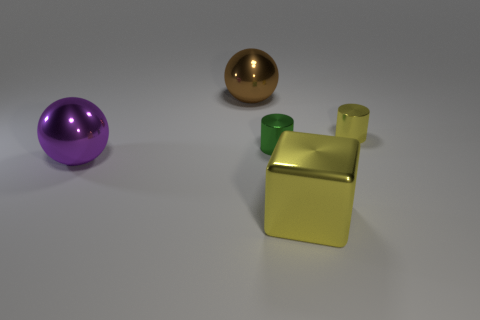There is a yellow metallic object that is on the left side of the small yellow cylinder; how big is it?
Keep it short and to the point. Large. How many cyan spheres are the same size as the brown metal sphere?
Your answer should be compact. 0. There is a yellow metal cube; is its size the same as the green thing right of the purple ball?
Your response must be concise. No. How many things are either metallic cylinders or tiny yellow things?
Your answer should be compact. 2. What number of cylinders are the same color as the large metal block?
Provide a short and direct response. 1. What shape is the other thing that is the same size as the green thing?
Provide a succinct answer. Cylinder. Are there any other tiny metal objects of the same shape as the small yellow metal thing?
Your answer should be compact. Yes. What number of spheres are the same material as the green cylinder?
Provide a short and direct response. 2. Do the yellow object that is behind the large yellow object and the cube have the same material?
Your response must be concise. Yes. Is the number of purple shiny objects left of the yellow cylinder greater than the number of tiny green metal things to the left of the green shiny cylinder?
Your answer should be compact. Yes. 